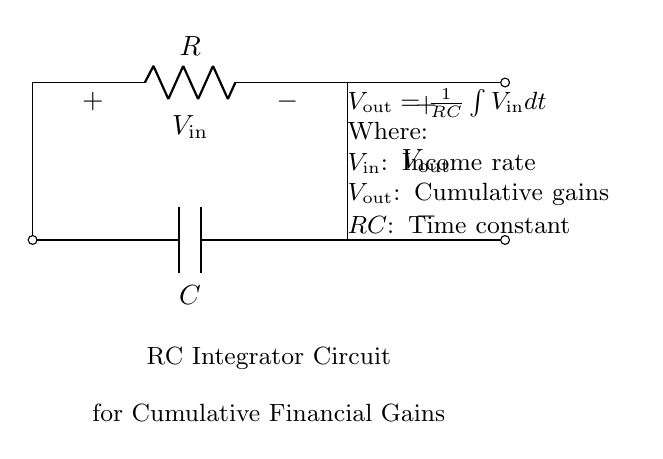What type of circuit is this? This circuit is an RC integrator circuit, which consists of a resistor and a capacitor configured to perform integration of the input voltage over time. The layout and components indicate this function.
Answer: RC integrator What does V in represent? V in represents the income rate, which is the voltage input to the integrator circuit correlating to the financial gains over time. This is specified in the circuit's annotation.
Answer: Income rate What does V out represent? V out represents the cumulative gains, which is the output voltage of the integrator circuit. This indicates the total accumulation of income over a period. This is also indicated in the circuit's annotation.
Answer: Cumulative gains What is the time constant of the circuit? The time constant, denoted as RC, is a key factor in determining the response time of the circuit to the input voltage. It reflects the product of the resistor and capacitor values in the circuit.
Answer: RC How does the circuit output relate to input over time? The output voltage, or cumulative gains, is the result of integrating the input income rate over time, as described by the equation shown in the circuit. It indicates how the effect of the input accumulates.
Answer: Integration What happens if the resistor value is increased? Increasing the resistor value will increase the time constant (RC), leading to a slower charging rate of the capacitor and a delayed response in the output voltage. This means the cumulative gain will build up more slowly over time.
Answer: Slower response 